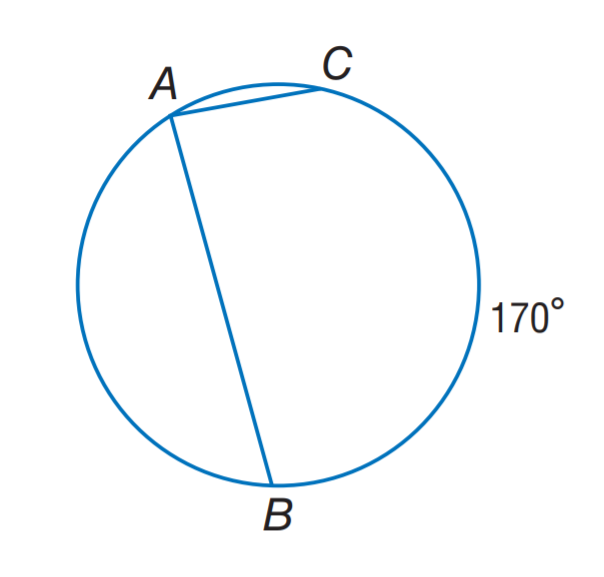Answer the mathemtical geometry problem and directly provide the correct option letter.
Question: Find m \angle A.
Choices: A: 42.5 B: 85 C: 95 D: 170 B 